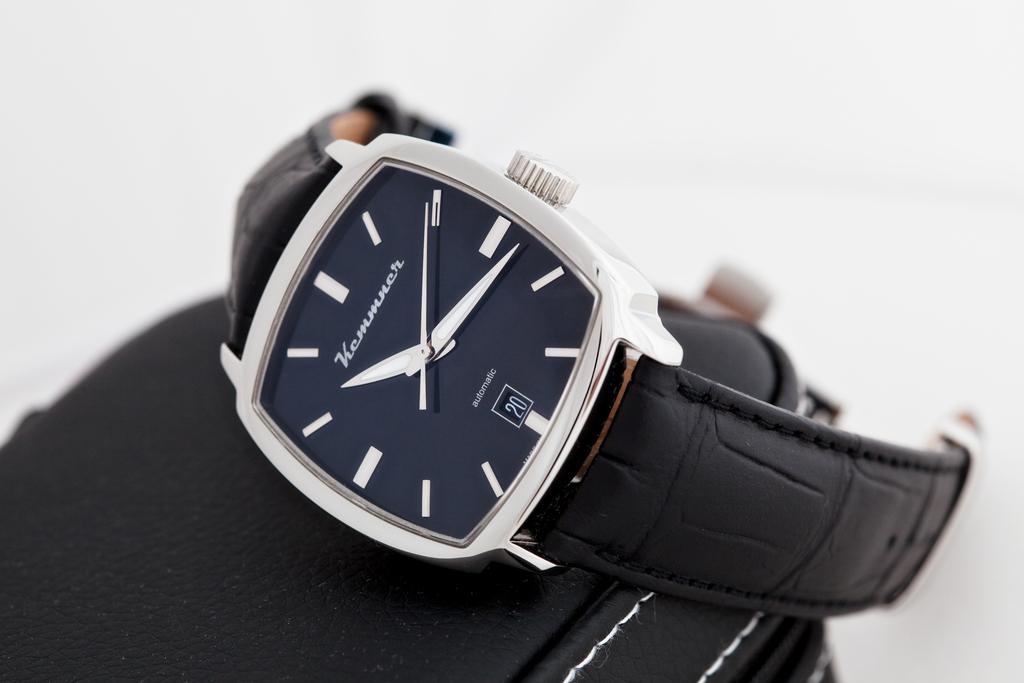The watch isin time 10.15?
Give a very brief answer. No. 